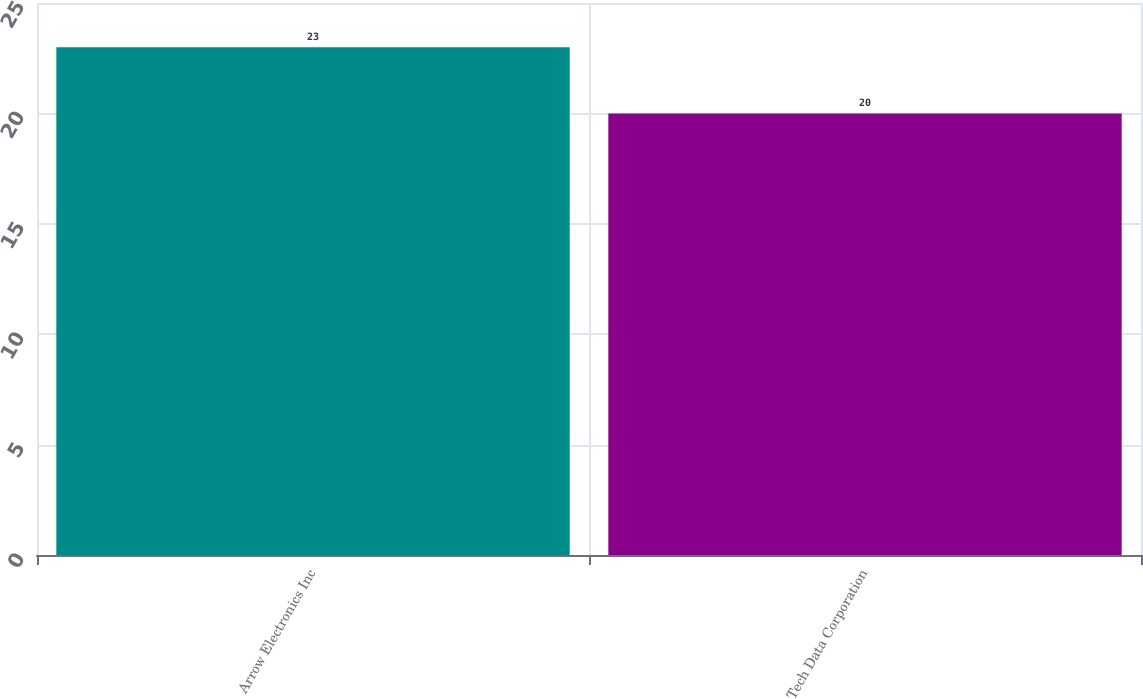<chart> <loc_0><loc_0><loc_500><loc_500><bar_chart><fcel>Arrow Electronics Inc<fcel>Tech Data Corporation<nl><fcel>23<fcel>20<nl></chart> 